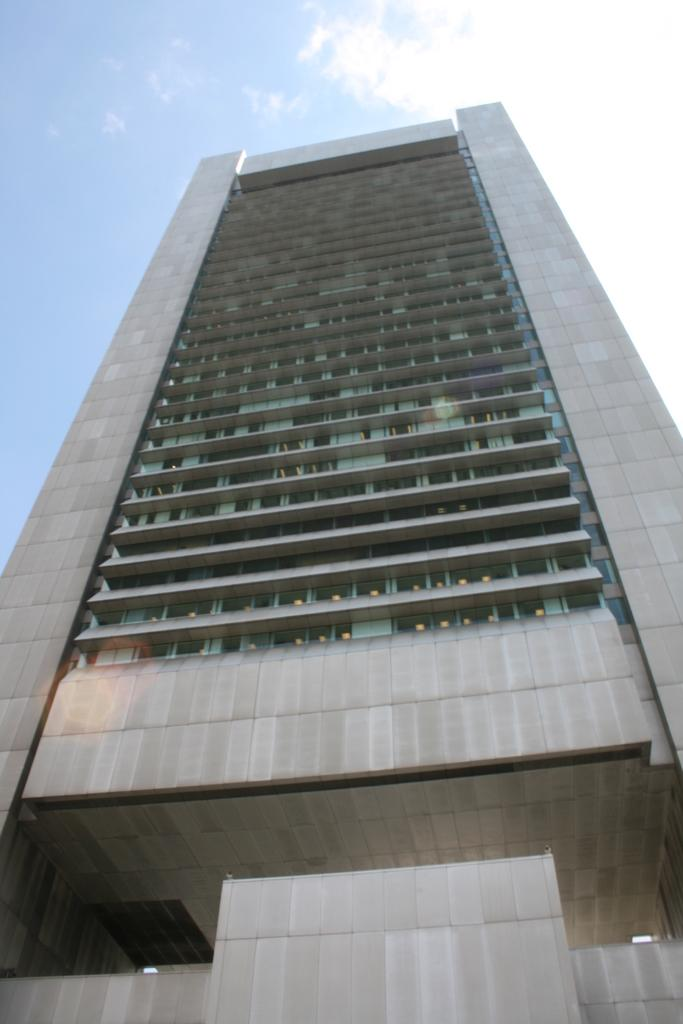What type of structure is visible in the image? There is a building in the image. What is visible at the top of the image? The sky is visible at the top of the image. What can be seen in the sky? Clouds are present in the sky. What type of pen is being used to draw the design on the liquid in the image? There is no pen, design, or liquid present in the image. 